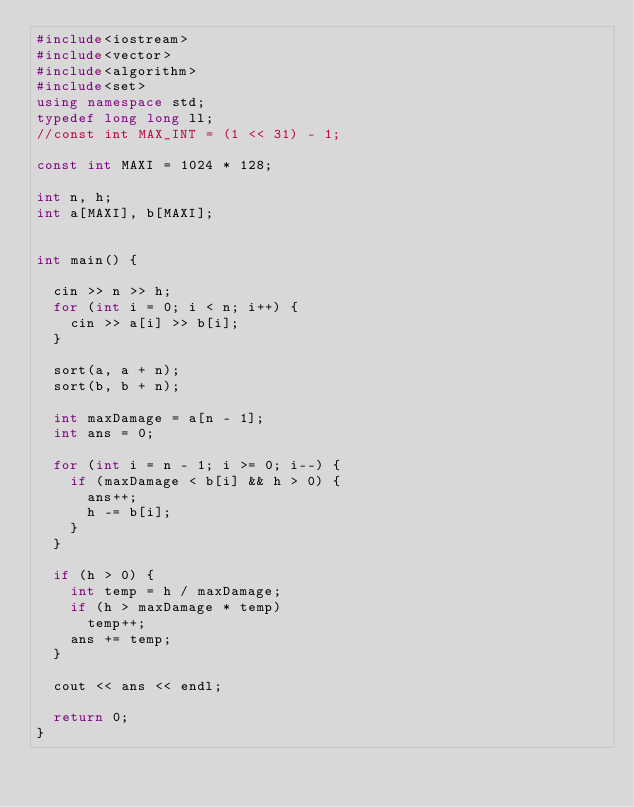Convert code to text. <code><loc_0><loc_0><loc_500><loc_500><_C++_>#include<iostream>
#include<vector>
#include<algorithm>
#include<set>
using namespace std;
typedef long long ll;
//const int MAX_INT = (1 << 31) - 1;

const int MAXI = 1024 * 128;

int n, h;
int a[MAXI], b[MAXI];


int main() {

	cin >> n >> h;
	for (int i = 0; i < n; i++) {
		cin >> a[i] >> b[i];
	}
	
	sort(a, a + n);
	sort(b, b + n);

	int maxDamage = a[n - 1];
	int ans = 0;

	for (int i = n - 1; i >= 0; i--) {
		if (maxDamage < b[i] && h > 0) {
			ans++;
			h -= b[i];
		}
	}

	if (h > 0) {
		int temp = h / maxDamage;
		if (h > maxDamage * temp)
			temp++;
		ans += temp;
	}

	cout << ans << endl;

	return 0;
}</code> 